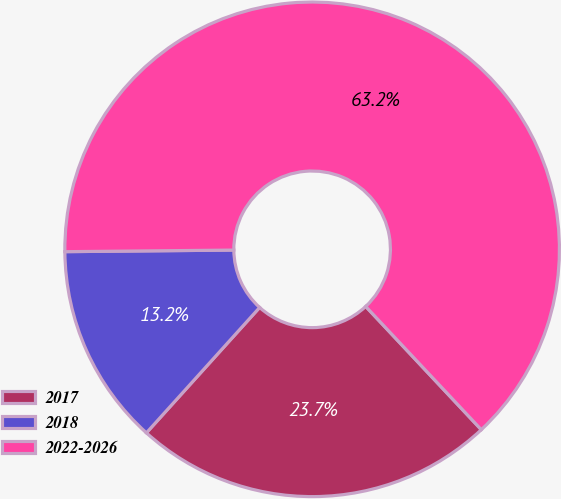Convert chart. <chart><loc_0><loc_0><loc_500><loc_500><pie_chart><fcel>2017<fcel>2018<fcel>2022-2026<nl><fcel>23.68%<fcel>13.16%<fcel>63.16%<nl></chart> 